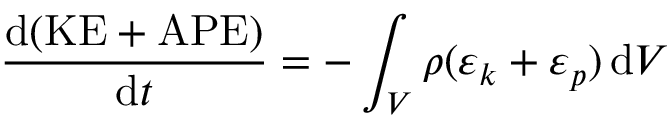<formula> <loc_0><loc_0><loc_500><loc_500>\frac { d ( K E + A P E ) } { d t } = - \int _ { V } \rho ( \varepsilon _ { k } + \varepsilon _ { p } ) \, d V</formula> 